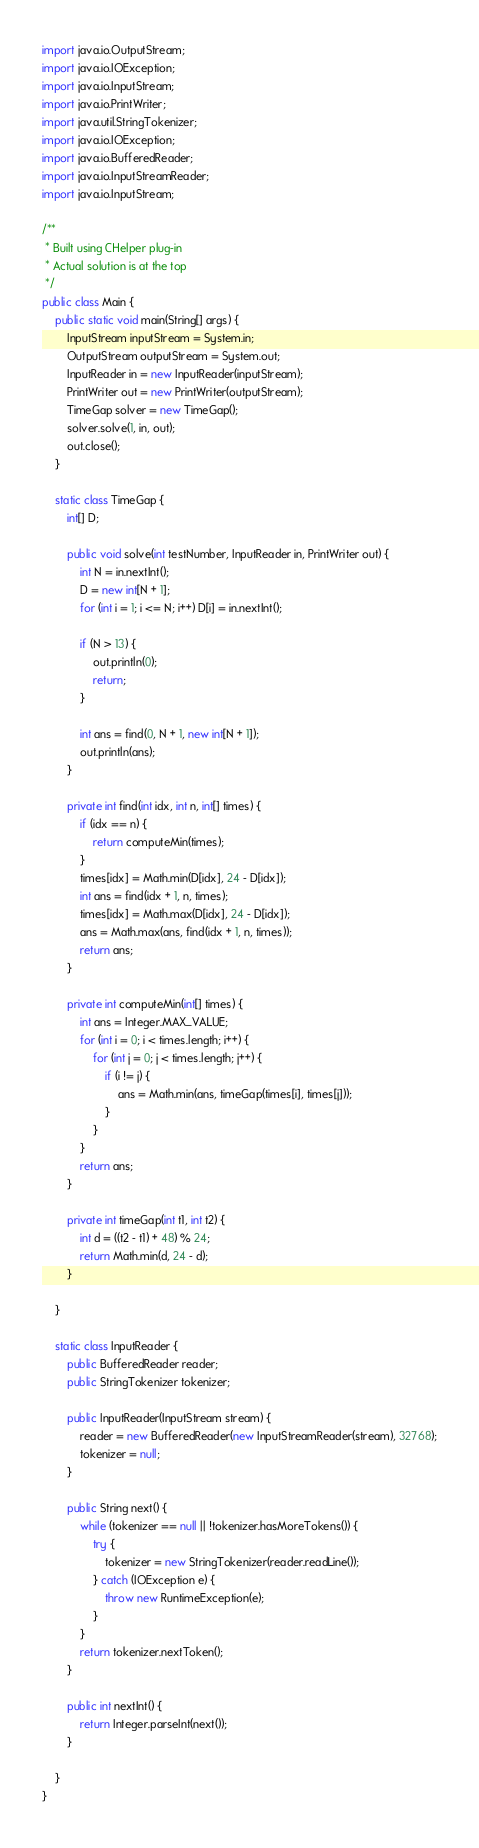Convert code to text. <code><loc_0><loc_0><loc_500><loc_500><_Java_>import java.io.OutputStream;
import java.io.IOException;
import java.io.InputStream;
import java.io.PrintWriter;
import java.util.StringTokenizer;
import java.io.IOException;
import java.io.BufferedReader;
import java.io.InputStreamReader;
import java.io.InputStream;

/**
 * Built using CHelper plug-in
 * Actual solution is at the top
 */
public class Main {
    public static void main(String[] args) {
        InputStream inputStream = System.in;
        OutputStream outputStream = System.out;
        InputReader in = new InputReader(inputStream);
        PrintWriter out = new PrintWriter(outputStream);
        TimeGap solver = new TimeGap();
        solver.solve(1, in, out);
        out.close();
    }

    static class TimeGap {
        int[] D;

        public void solve(int testNumber, InputReader in, PrintWriter out) {
            int N = in.nextInt();
            D = new int[N + 1];
            for (int i = 1; i <= N; i++) D[i] = in.nextInt();

            if (N > 13) {
                out.println(0);
                return;
            }

            int ans = find(0, N + 1, new int[N + 1]);
            out.println(ans);
        }

        private int find(int idx, int n, int[] times) {
            if (idx == n) {
                return computeMin(times);
            }
            times[idx] = Math.min(D[idx], 24 - D[idx]);
            int ans = find(idx + 1, n, times);
            times[idx] = Math.max(D[idx], 24 - D[idx]);
            ans = Math.max(ans, find(idx + 1, n, times));
            return ans;
        }

        private int computeMin(int[] times) {
            int ans = Integer.MAX_VALUE;
            for (int i = 0; i < times.length; i++) {
                for (int j = 0; j < times.length; j++) {
                    if (i != j) {
                        ans = Math.min(ans, timeGap(times[i], times[j]));
                    }
                }
            }
            return ans;
        }

        private int timeGap(int t1, int t2) {
            int d = ((t2 - t1) + 48) % 24;
            return Math.min(d, 24 - d);
        }

    }

    static class InputReader {
        public BufferedReader reader;
        public StringTokenizer tokenizer;

        public InputReader(InputStream stream) {
            reader = new BufferedReader(new InputStreamReader(stream), 32768);
            tokenizer = null;
        }

        public String next() {
            while (tokenizer == null || !tokenizer.hasMoreTokens()) {
                try {
                    tokenizer = new StringTokenizer(reader.readLine());
                } catch (IOException e) {
                    throw new RuntimeException(e);
                }
            }
            return tokenizer.nextToken();
        }

        public int nextInt() {
            return Integer.parseInt(next());
        }

    }
}

</code> 